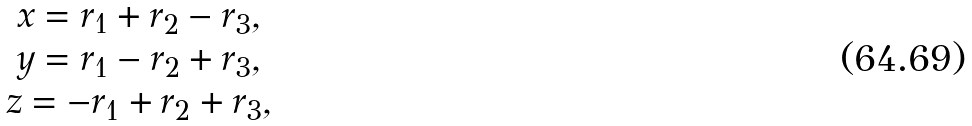Convert formula to latex. <formula><loc_0><loc_0><loc_500><loc_500>\begin{array} { c } x = r _ { 1 } + r _ { 2 } - r _ { 3 } , \\ y = r _ { 1 } - r _ { 2 } + r _ { 3 } , \\ z = - r _ { 1 } + r _ { 2 } + r _ { 3 } , \\ \end{array}</formula> 